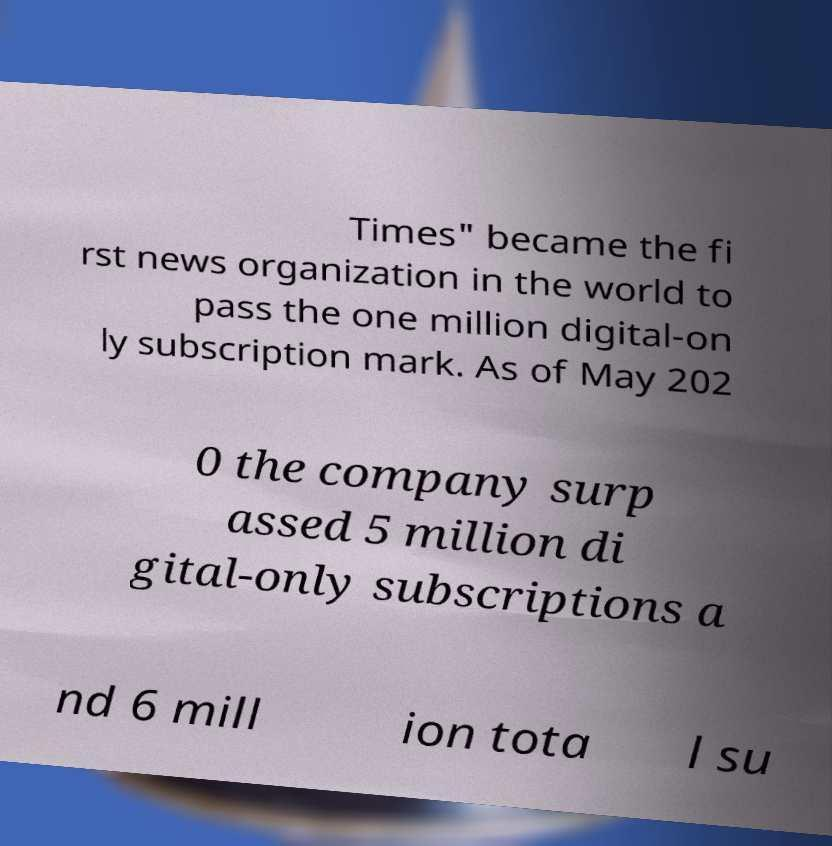Could you extract and type out the text from this image? Times" became the fi rst news organization in the world to pass the one million digital-on ly subscription mark. As of May 202 0 the company surp assed 5 million di gital-only subscriptions a nd 6 mill ion tota l su 